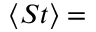<formula> <loc_0><loc_0><loc_500><loc_500>\langle S t \rangle =</formula> 